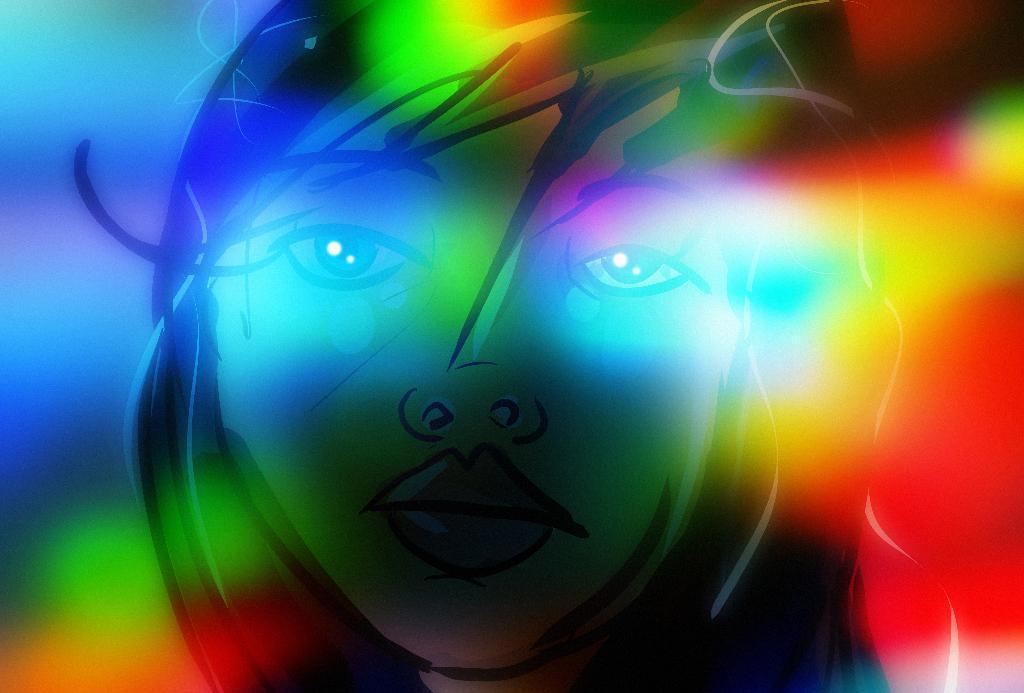Please provide a concise description of this image. This is an animated image of a woman's face. 